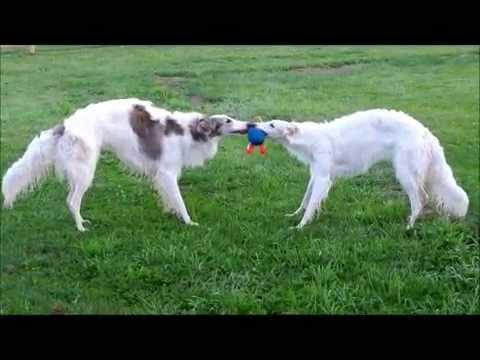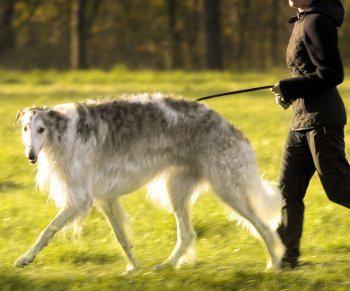The first image is the image on the left, the second image is the image on the right. Examine the images to the left and right. Is the description "A woman's legs are seen next to dog." accurate? Answer yes or no. Yes. 